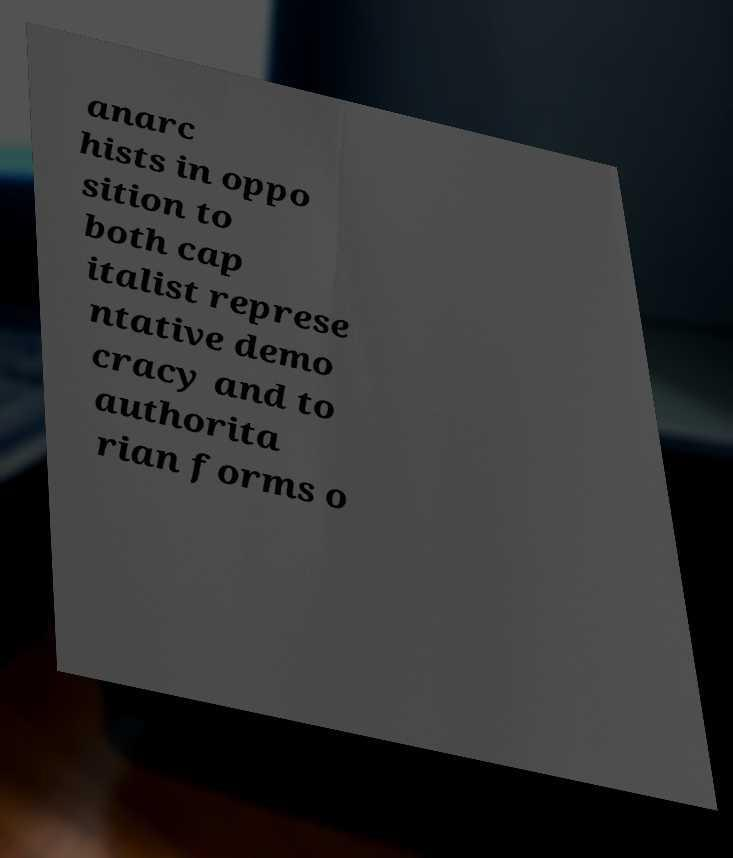What messages or text are displayed in this image? I need them in a readable, typed format. anarc hists in oppo sition to both cap italist represe ntative demo cracy and to authorita rian forms o 